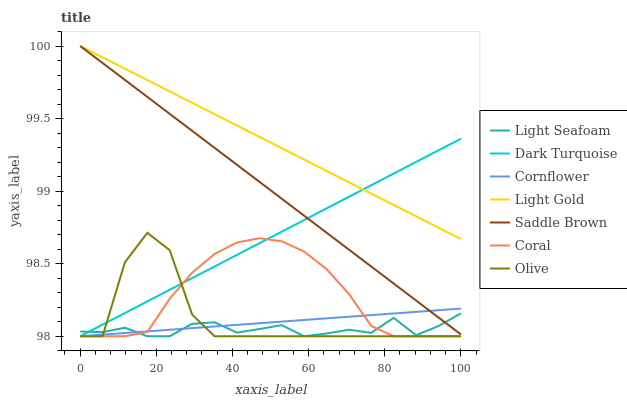Does Light Seafoam have the minimum area under the curve?
Answer yes or no. Yes. Does Light Gold have the maximum area under the curve?
Answer yes or no. Yes. Does Dark Turquoise have the minimum area under the curve?
Answer yes or no. No. Does Dark Turquoise have the maximum area under the curve?
Answer yes or no. No. Is Cornflower the smoothest?
Answer yes or no. Yes. Is Olive the roughest?
Answer yes or no. Yes. Is Dark Turquoise the smoothest?
Answer yes or no. No. Is Dark Turquoise the roughest?
Answer yes or no. No. Does Light Gold have the lowest value?
Answer yes or no. No. Does Dark Turquoise have the highest value?
Answer yes or no. No. Is Light Seafoam less than Light Gold?
Answer yes or no. Yes. Is Light Gold greater than Cornflower?
Answer yes or no. Yes. Does Light Seafoam intersect Light Gold?
Answer yes or no. No. 